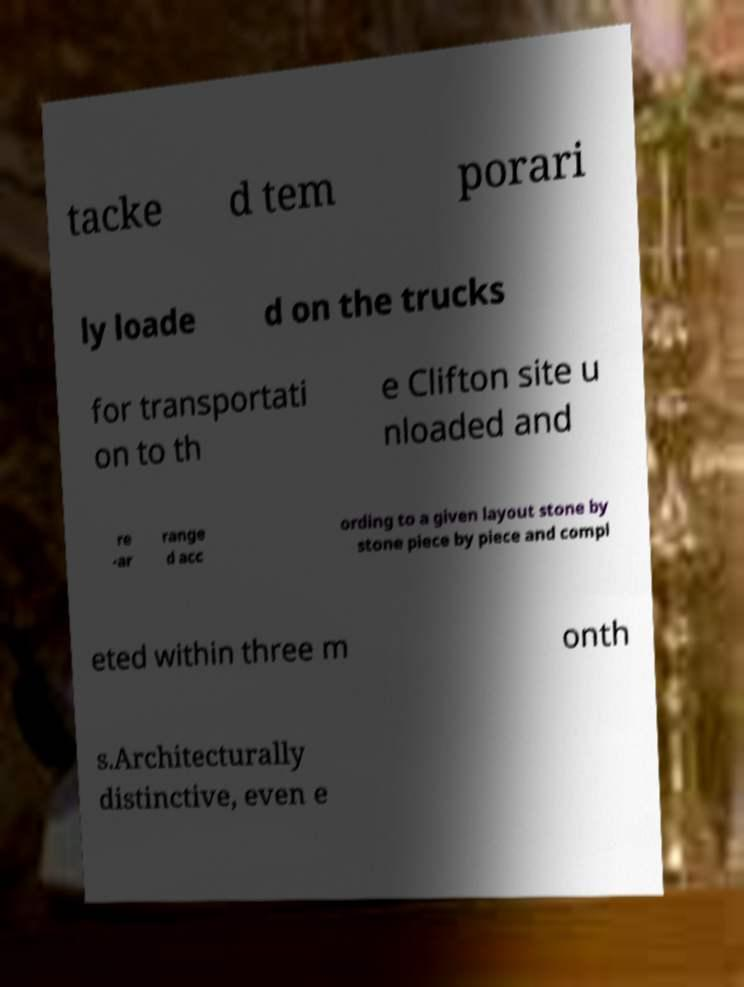I need the written content from this picture converted into text. Can you do that? tacke d tem porari ly loade d on the trucks for transportati on to th e Clifton site u nloaded and re -ar range d acc ording to a given layout stone by stone piece by piece and compl eted within three m onth s.Architecturally distinctive, even e 